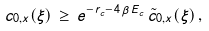Convert formula to latex. <formula><loc_0><loc_0><loc_500><loc_500>c _ { 0 , x } ( \xi ) \, \geq \, e ^ { - r _ { c } - 4 \, \beta \, E _ { c } } \, \tilde { c } _ { 0 , x } ( \xi ) \, ,</formula> 